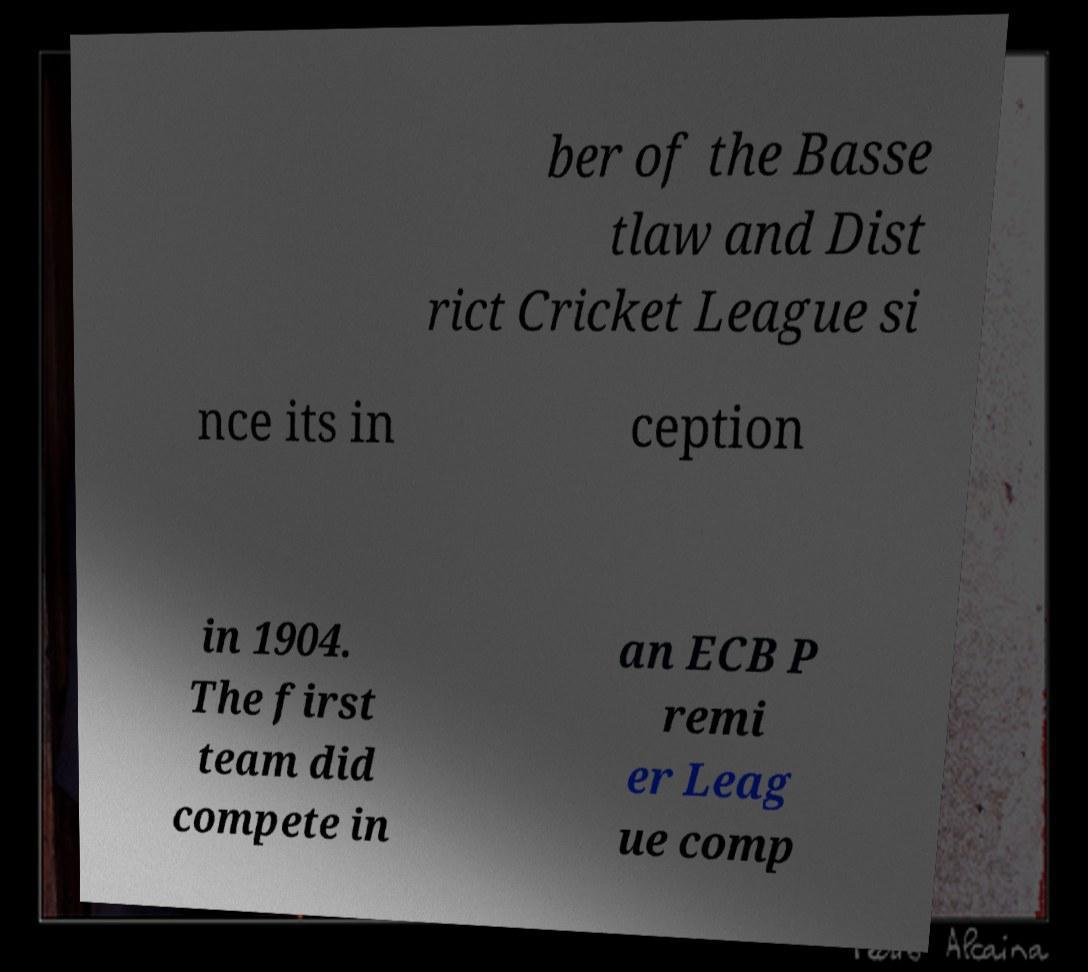Could you assist in decoding the text presented in this image and type it out clearly? ber of the Basse tlaw and Dist rict Cricket League si nce its in ception in 1904. The first team did compete in an ECB P remi er Leag ue comp 